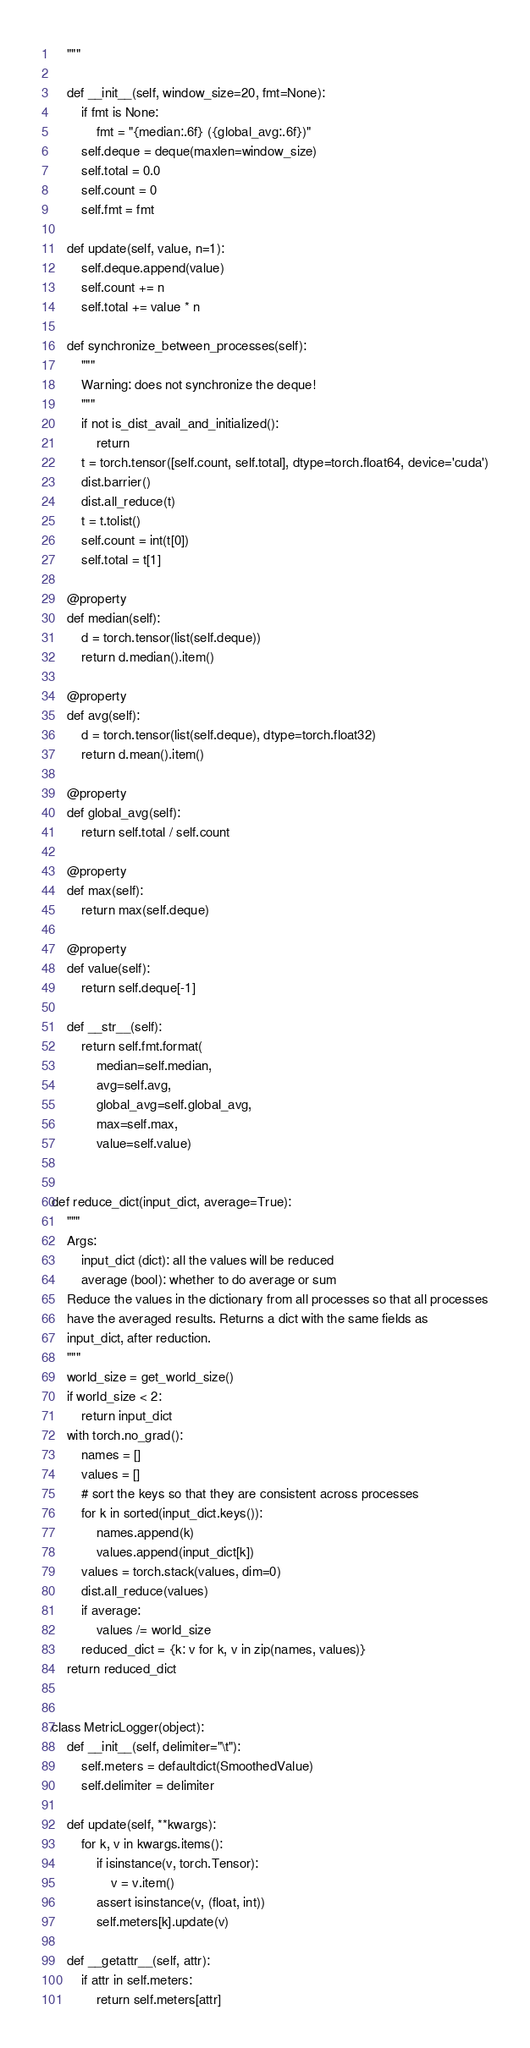<code> <loc_0><loc_0><loc_500><loc_500><_Python_>    """

    def __init__(self, window_size=20, fmt=None):
        if fmt is None:
            fmt = "{median:.6f} ({global_avg:.6f})"
        self.deque = deque(maxlen=window_size)
        self.total = 0.0
        self.count = 0
        self.fmt = fmt

    def update(self, value, n=1):
        self.deque.append(value)
        self.count += n
        self.total += value * n

    def synchronize_between_processes(self):
        """
        Warning: does not synchronize the deque!
        """
        if not is_dist_avail_and_initialized():
            return
        t = torch.tensor([self.count, self.total], dtype=torch.float64, device='cuda')
        dist.barrier()
        dist.all_reduce(t)
        t = t.tolist()
        self.count = int(t[0])
        self.total = t[1]

    @property
    def median(self):
        d = torch.tensor(list(self.deque))
        return d.median().item()

    @property
    def avg(self):
        d = torch.tensor(list(self.deque), dtype=torch.float32)
        return d.mean().item()

    @property
    def global_avg(self):
        return self.total / self.count

    @property
    def max(self):
        return max(self.deque)

    @property
    def value(self):
        return self.deque[-1]

    def __str__(self):
        return self.fmt.format(
            median=self.median,
            avg=self.avg,
            global_avg=self.global_avg,
            max=self.max,
            value=self.value)


def reduce_dict(input_dict, average=True):
    """
    Args:
        input_dict (dict): all the values will be reduced
        average (bool): whether to do average or sum
    Reduce the values in the dictionary from all processes so that all processes
    have the averaged results. Returns a dict with the same fields as
    input_dict, after reduction.
    """
    world_size = get_world_size()
    if world_size < 2:
        return input_dict
    with torch.no_grad():
        names = []
        values = []
        # sort the keys so that they are consistent across processes
        for k in sorted(input_dict.keys()):
            names.append(k)
            values.append(input_dict[k])
        values = torch.stack(values, dim=0)
        dist.all_reduce(values)
        if average:
            values /= world_size
        reduced_dict = {k: v for k, v in zip(names, values)}
    return reduced_dict


class MetricLogger(object):
    def __init__(self, delimiter="\t"):
        self.meters = defaultdict(SmoothedValue)
        self.delimiter = delimiter

    def update(self, **kwargs):
        for k, v in kwargs.items():
            if isinstance(v, torch.Tensor):
                v = v.item()
            assert isinstance(v, (float, int))
            self.meters[k].update(v)

    def __getattr__(self, attr):
        if attr in self.meters:
            return self.meters[attr]</code> 